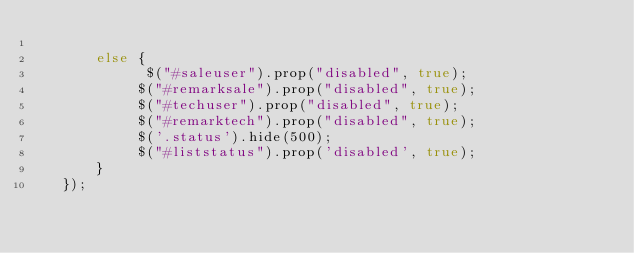Convert code to text. <code><loc_0><loc_0><loc_500><loc_500><_PHP_>
       else {
             $("#saleuser").prop("disabled", true);
            $("#remarksale").prop("disabled", true);
            $("#techuser").prop("disabled", true);
            $("#remarktech").prop("disabled", true);
            $('.status').hide(500); 
            $("#liststatus").prop('disabled', true); 
       }
   });
</code> 